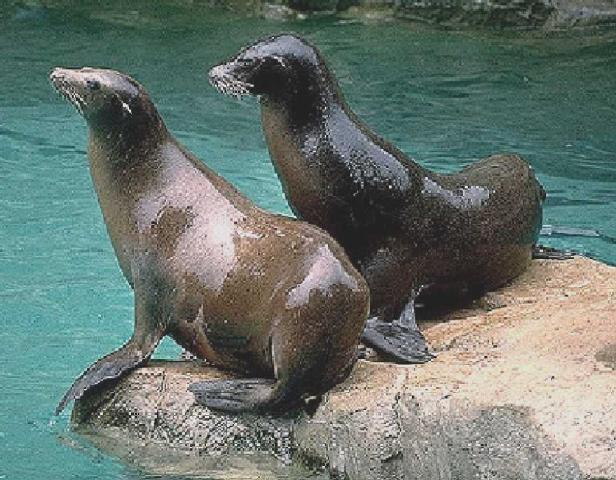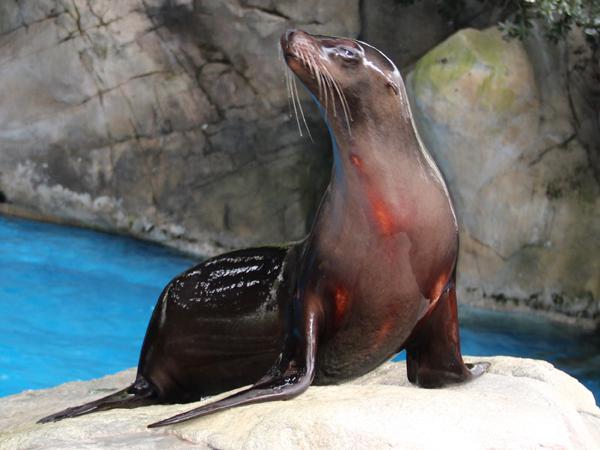The first image is the image on the left, the second image is the image on the right. Examine the images to the left and right. Is the description "There is exactly one seal sitting on a rock in the image on the right." accurate? Answer yes or no. Yes. 